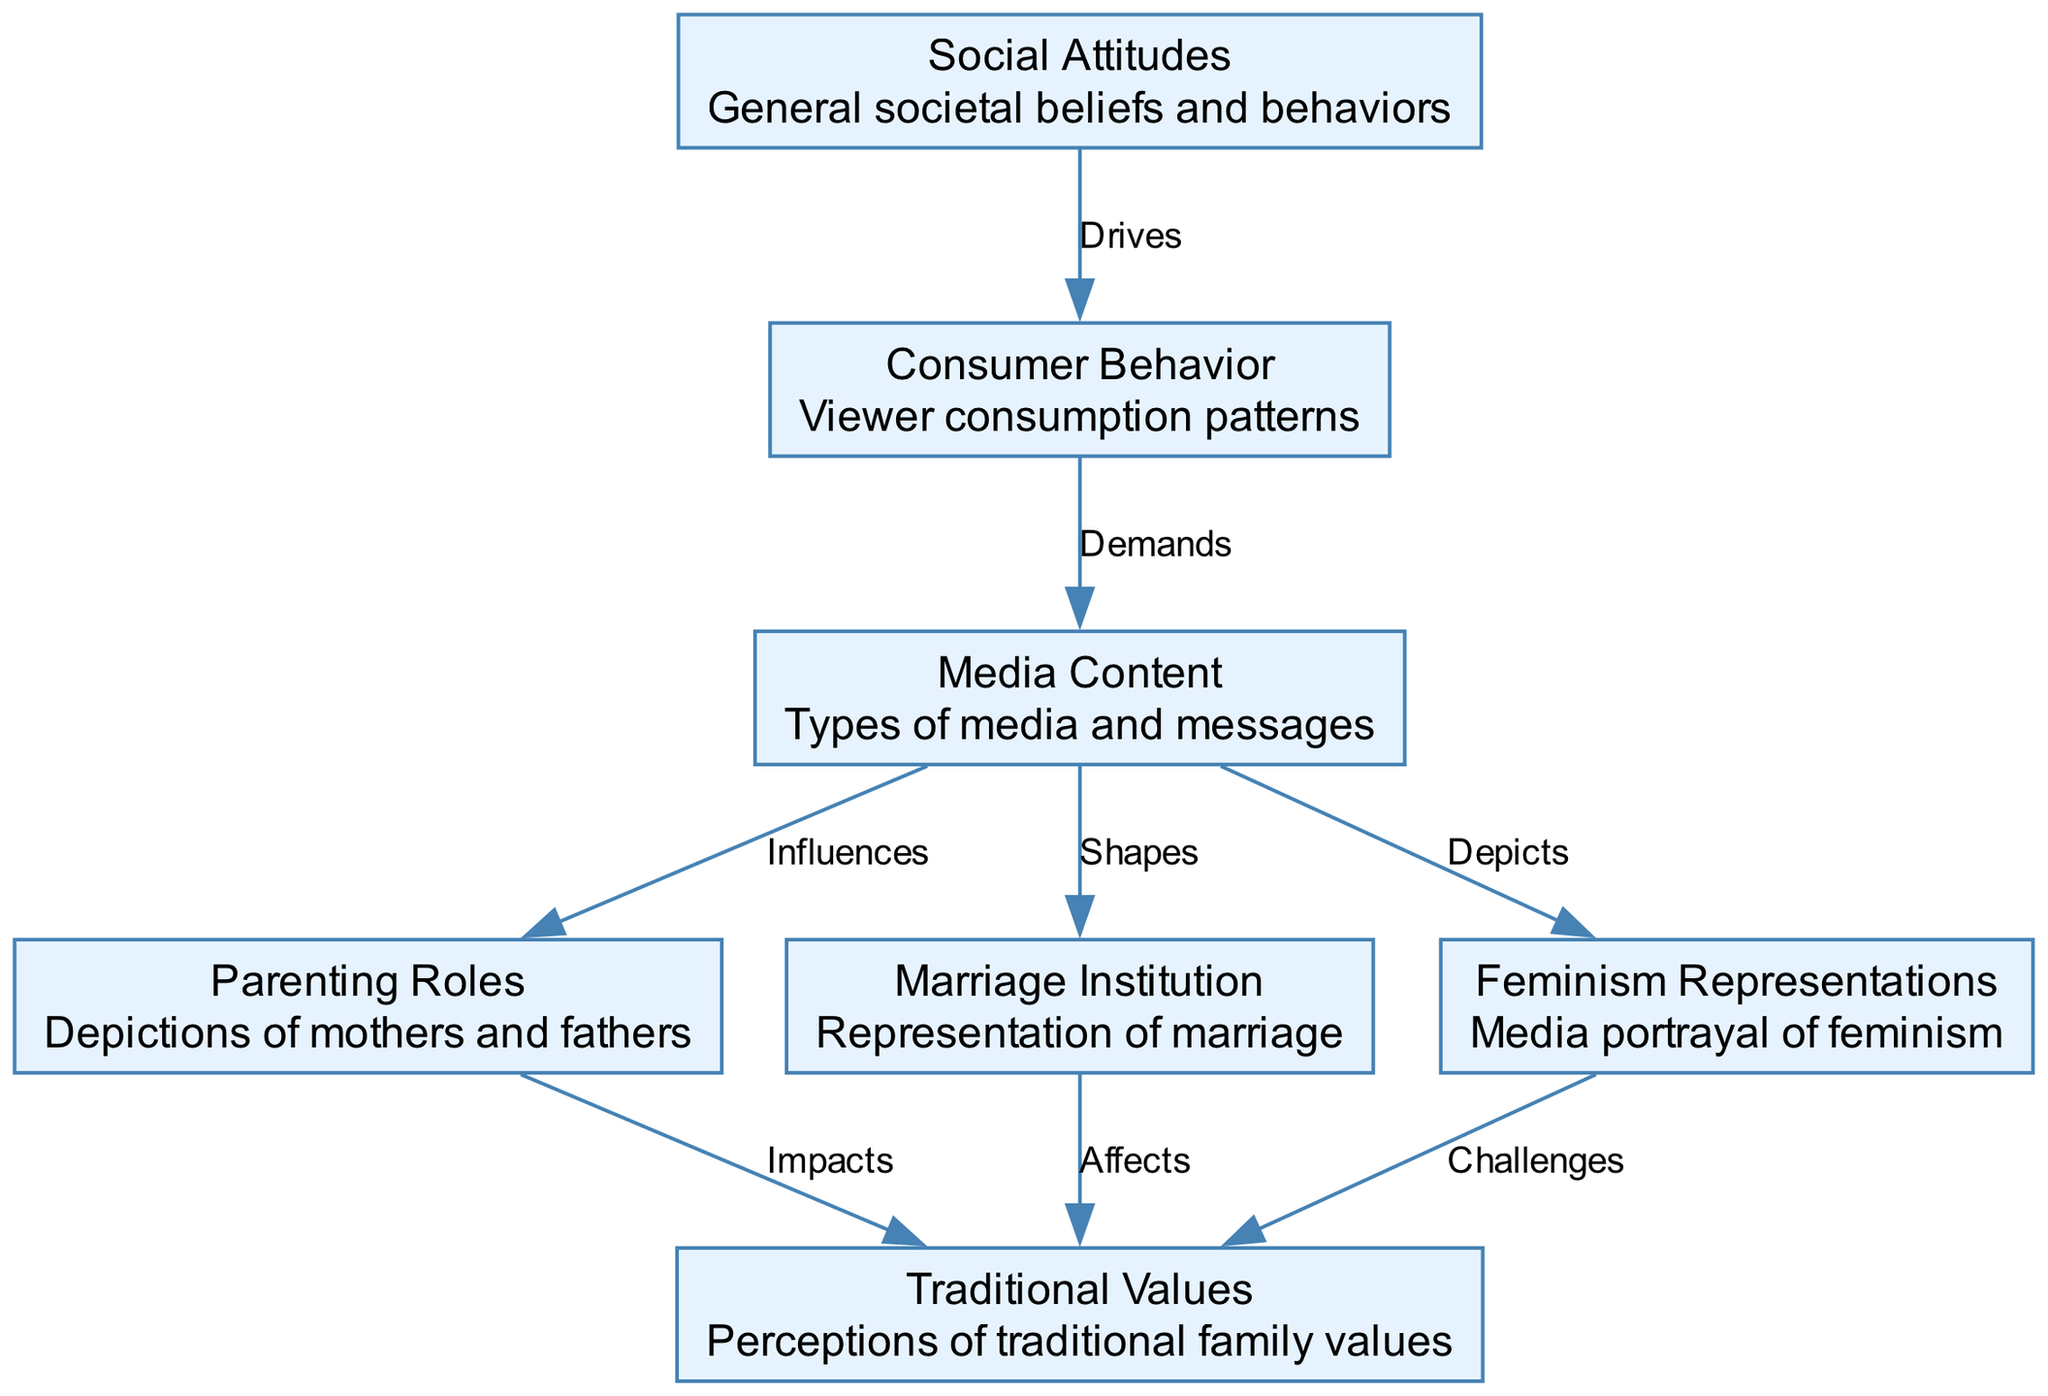What is the total number of nodes in the diagram? The diagram lists the following nodes: Media Content, Parenting Roles, Marriage Institution, Feminism Representations, Traditional Values, Consumer Behavior, and Social Attitudes. Counting these gives a total of 7 nodes.
Answer: 7 Which node represents the depiction of mothers and fathers? The node labeled "Parenting Roles" specifically describes the depictions of mothers and fathers in the diagram.
Answer: Parenting Roles What relationship does "feminism representations" have with "traditional values"? The line labeled "Challenges" indicates that feminism representations challenge traditional values, showing a direct relationship where feminism influences perceptions of traditional family values negatively.
Answer: Challenges How many edges are connected to the "media content" node? The edges connected to media content are: influences parenting roles, shapes marriage institution, and depicts feminism representations. This gives a total of 3 edges connected to the media content node.
Answer: 3 Which node is influenced by consumer behavior? The node that is influenced by consumer behavior is "media content," as indicated by the edge marked "Demands," showing that consumer behavior drives the demand for certain media content.
Answer: Media Content What is the impact of "parenting roles" on "traditional values"? The diagram shows an edge from parenting roles to traditional values labeled "Impacts," indicating that parenting roles have an effect on perceptions of traditional values.
Answer: Impacts How do social attitudes relate to consumer behavior? The edge labeled "Drives" connects social attitudes to consumer behavior, indicating that societal beliefs and behaviors influence how consumers act or what they consume.
Answer: Drives Which node directly affects "traditional values" related to marriage? The node labeled "Marriage Institution" directly affects traditional values, as represented by the edge labeled "Affects." This suggests that the way marriage is portrayed impacts perceptions of traditional family structures.
Answer: Affects What two nodes are directly influenced by "media content"? Media content directly influences "parenting roles" and "marriage institution." These relationships indicate that portrayals in media shape societal expectations around these areas.
Answer: Parenting Roles, Marriage Institution 